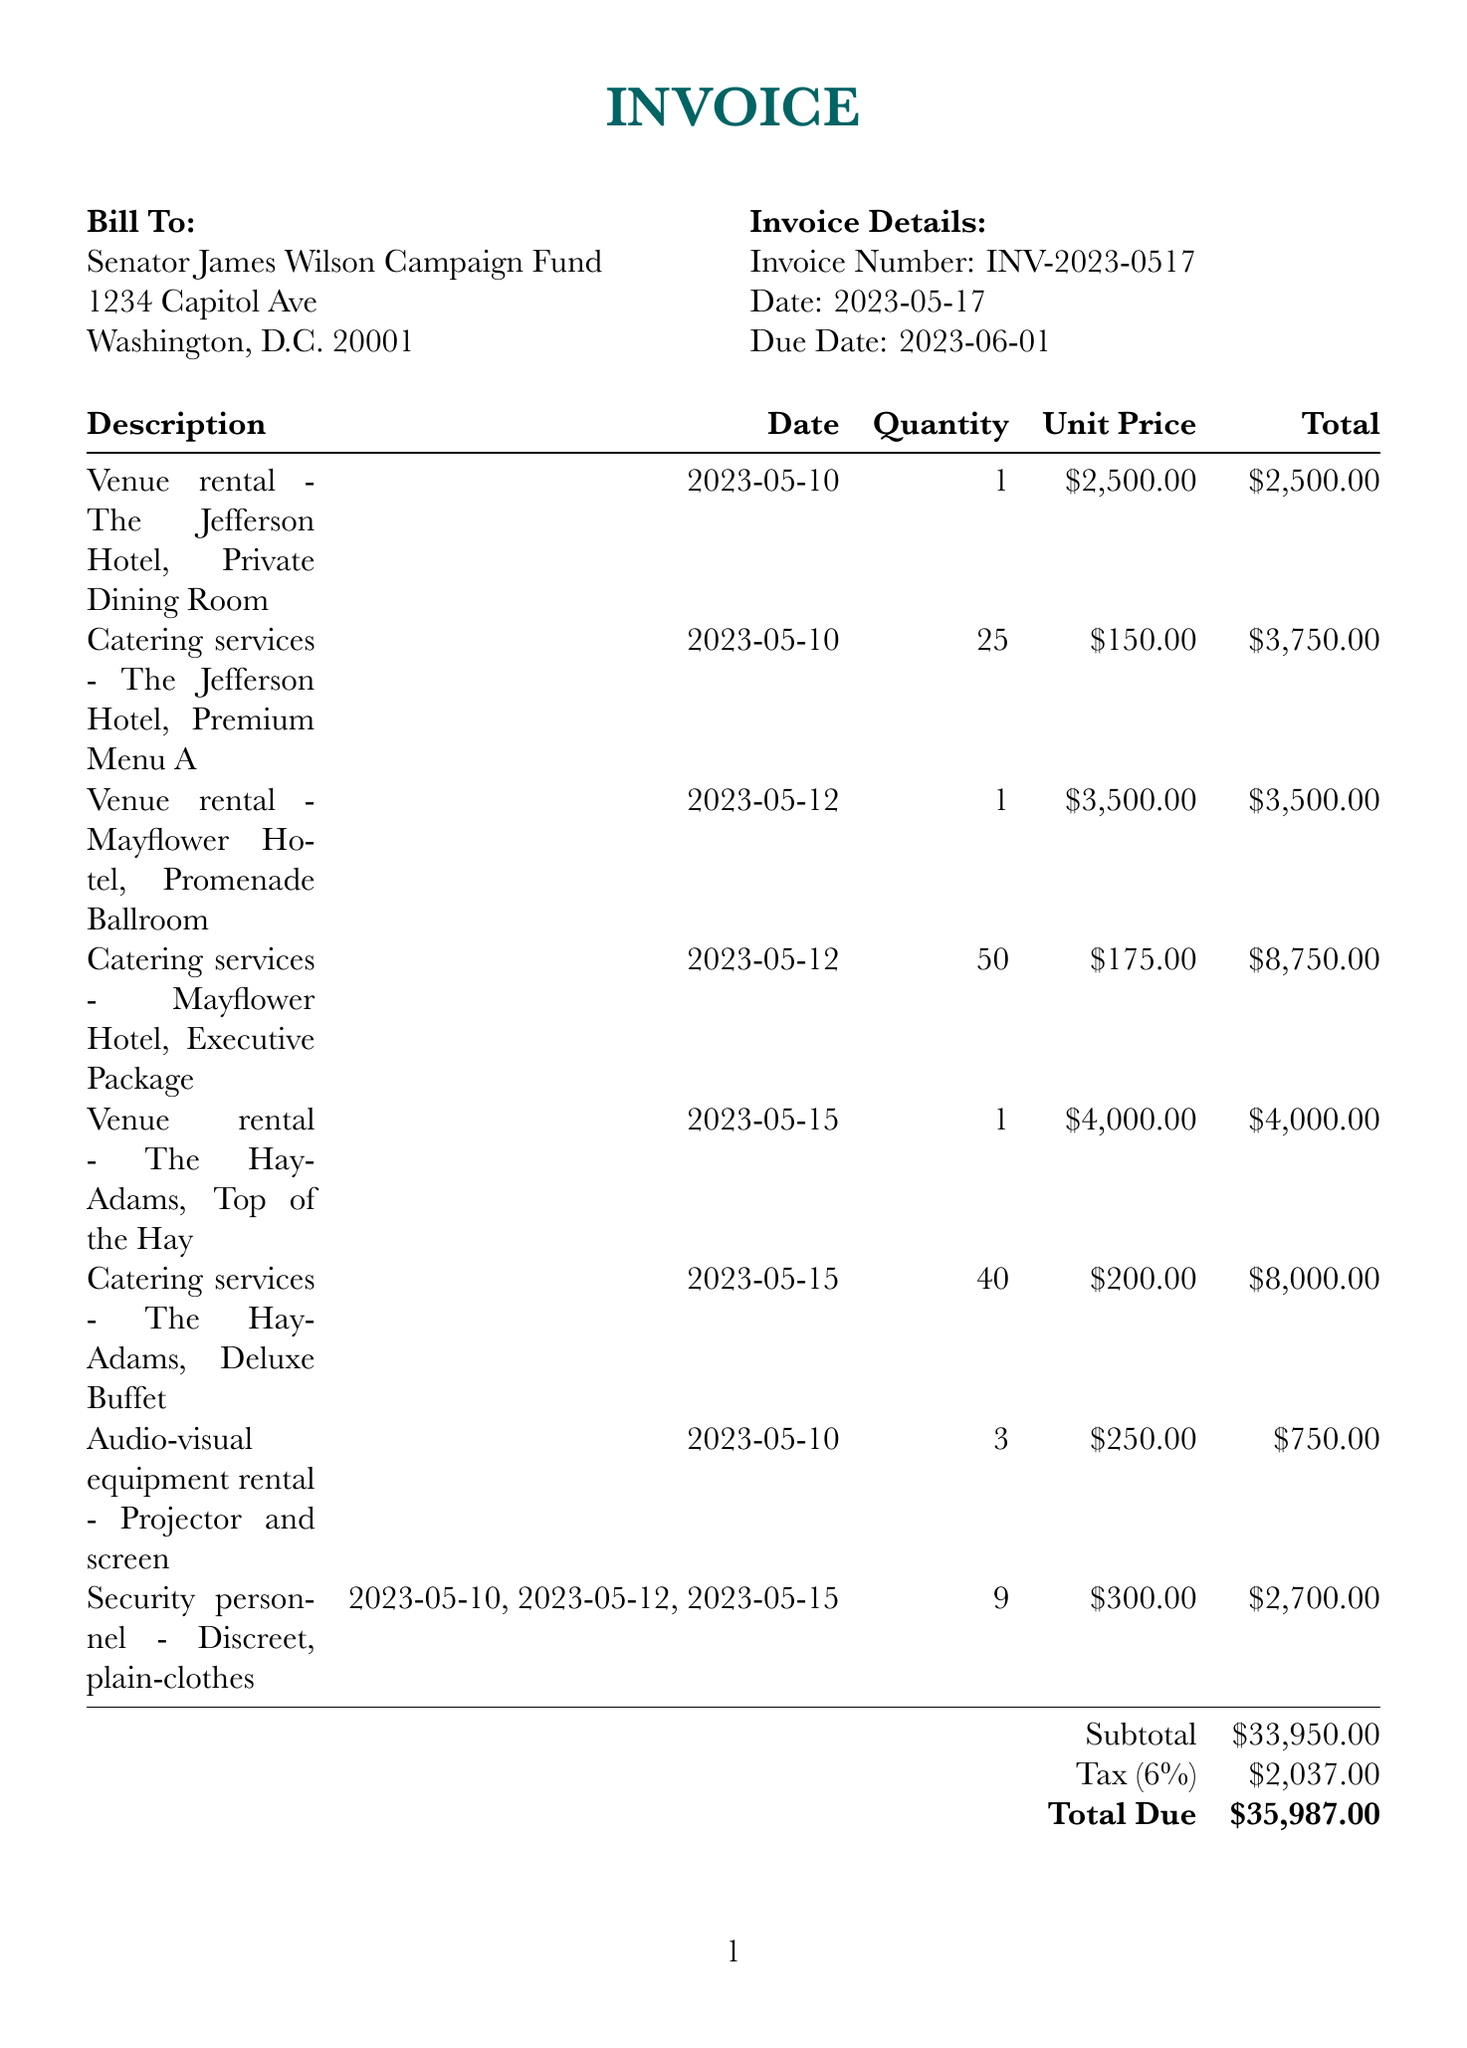What is the invoice number? The invoice number is listed at the top of the document under invoice details, which identifies the specific invoice.
Answer: INV-2023-0517 Who is the client? The client is mentioned in the document as the entity responsible for the payment, which helps identify the payer.
Answer: Senator James Wilson Campaign Fund What is the total due amount? The total due amount is calculated as the sum of subtotal and tax, reflecting the final amount payable.
Answer: $35,987.00 When is the due date for payment? The due date is specified in the invoice details section, showing when payment is expected.
Answer: 2023-06-01 How many catering services were provided at The Hay-Adams? This quantity highlights the specific catering arrangement for the event, which can influence budgeting and planning.
Answer: 40 What was the unit price for the venue rental at The Jefferson Hotel? Knowing this cost helps assess the financial implications of venue selection for events.
Answer: $2,500.00 What is the subtotal before tax? The subtotal is the total before adding any tax, indicating the base cost of services rendered.
Answer: $33,950.00 What type of personnel was hired for the events? Identifying the type of personnel helps evaluate security and discretion for the closed-door meetings mentioned in the notes.
Answer: Discreet, plain-clothes Who wrote the notes? The writer of the notes provides context and insight into the relationship with the client, highlighting trust and familiarity.
Answer: Your trusted confidant 